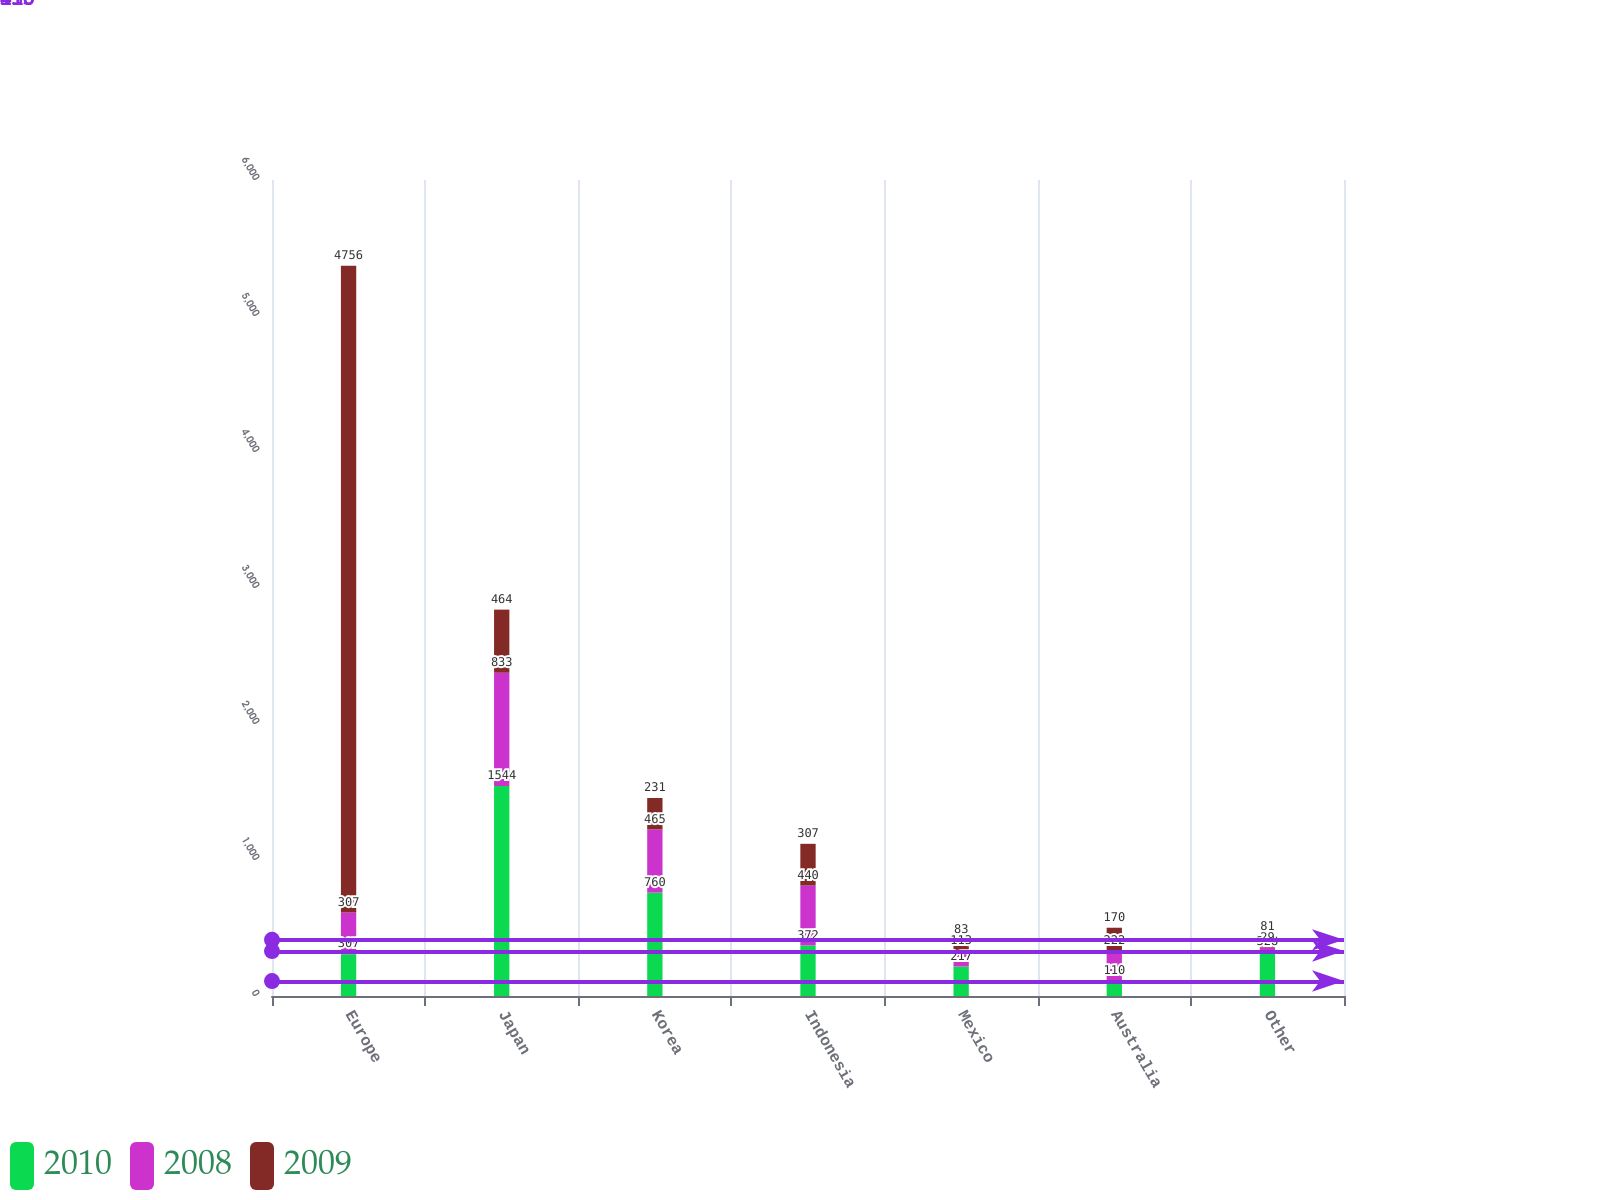Convert chart to OTSL. <chart><loc_0><loc_0><loc_500><loc_500><stacked_bar_chart><ecel><fcel>Europe<fcel>Japan<fcel>Korea<fcel>Indonesia<fcel>Mexico<fcel>Australia<fcel>Other<nl><fcel>2010<fcel>307<fcel>1544<fcel>760<fcel>372<fcel>217<fcel>110<fcel>328<nl><fcel>2008<fcel>307<fcel>833<fcel>465<fcel>440<fcel>113<fcel>222<fcel>29<nl><fcel>2009<fcel>4756<fcel>464<fcel>231<fcel>307<fcel>83<fcel>170<fcel>81<nl></chart> 